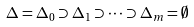Convert formula to latex. <formula><loc_0><loc_0><loc_500><loc_500>\Delta = \Delta _ { 0 } \supset \Delta _ { 1 } \supset \dots \supset \Delta _ { m } = \emptyset</formula> 